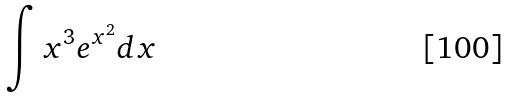<formula> <loc_0><loc_0><loc_500><loc_500>\int x ^ { 3 } e ^ { x ^ { 2 } } d x</formula> 